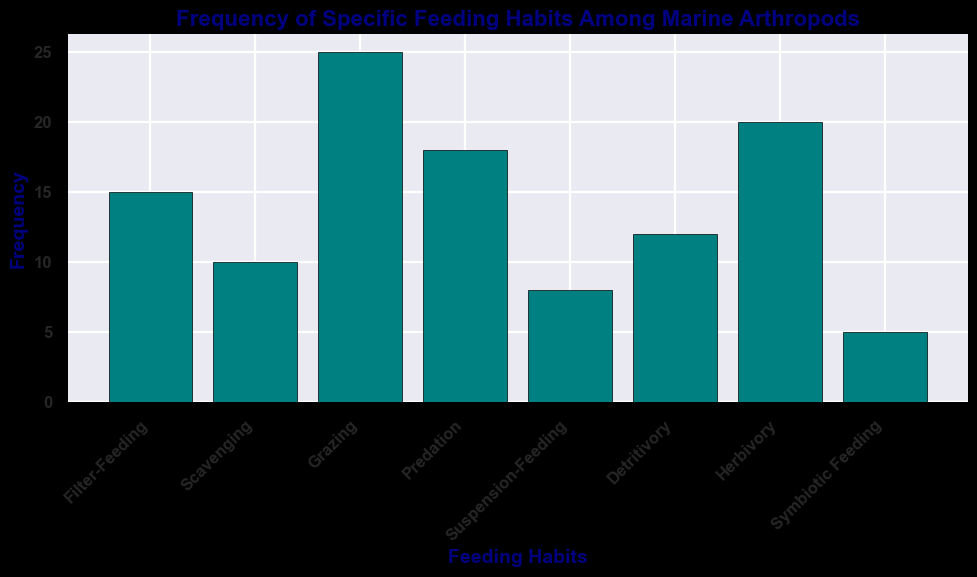Which feeding habit is observed most frequently among marine arthropods? The feeding habit observed most frequently is represented by the tallest bar. By looking at the chart, the "Grazing" bar is the tallest.
Answer: Grazing Which feeding habit has the lowest frequency? The feeding habit with the lowest frequency is represented by the shortest bar. By looking at the chart, "Symbiotic Feeding" has the shortest bar.
Answer: Symbiotic Feeding How many more marine arthropods exhibit grazing compared to scavenging? To find this, identify the frequencies of both grazing and scavenging. Grazing has a frequency of 25 and scavenging has 10. The difference is calculated as 25 - 10.
Answer: 15 What is the combined frequency of detritivory and herbivory? Add the frequencies of detritivory and herbivory together. Detritivory has a frequency of 12 and herbivory has 20. Therefore, 12 + 20.
Answer: 32 Which is more prevalent: suspension-feeding or filter-feeding, and by how much? Compare the frequencies of suspension-feeding and filter-feeding. Suspension-feeding has a frequency of 8 and filter-feeding has 15. The difference is 15 - 8.
Answer: Filter-feeding, by 7 What is the total frequency of all feeding habits combined? Sum the frequencies of all the bars. 15 (Filter-Feeding) + 10 (Scavenging) + 25 (Grazing) + 18 (Predation) + 8 (Suspension-Feeding) + 12 (Detritivory) + 20 (Herbivory) + 5 (Symbiotic Feeding) = 113.
Answer: 113 Is predation more or less common than herbivory, and by how much? Compare the frequencies of predation and herbivory. Predation has a frequency of 18 and herbivory has 20. The difference is 20 - 18.
Answer: Less common by 2 Which feeding habits have frequencies above 15? Identify the feeding habits with frequencies greater than 15. Grazing (25), Predation (18), and Herbivory (20) are the only feeding habits above 15.
Answer: Grazing, Predation, Herbivory What proportion of the total frequency is accounted for by the top two feeding habits? First, find the top two feeding habits (Grazing with 25 and Herbivory with 20), then sum them (25 + 20), and finally divide by the total frequency (45 / 113). The proportion is approximately 0.398.
Answer: Approximately 0.398 Is there an equal number of feeding habits with frequencies below and above 10? Count the number of feeding habits with frequencies below 10 and those with frequencies above 10. Below 10: Scavenging, Suspension-Feeding, Symbiotic Feeding (3 habits). Above 10: Filter-Feeding, Grazing, Predation, Detritivory, Herbivory (5 habits).
Answer: No 